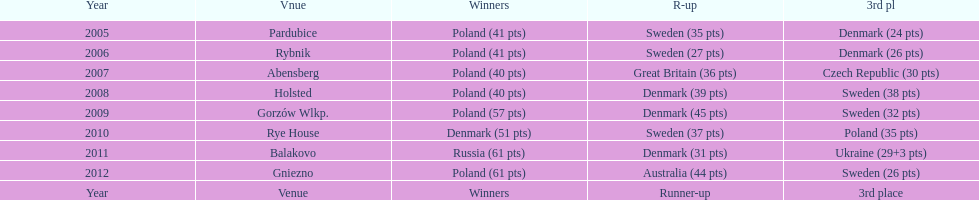After their first place win in 2009, how did poland place the next year at the speedway junior world championship? 3rd place. 